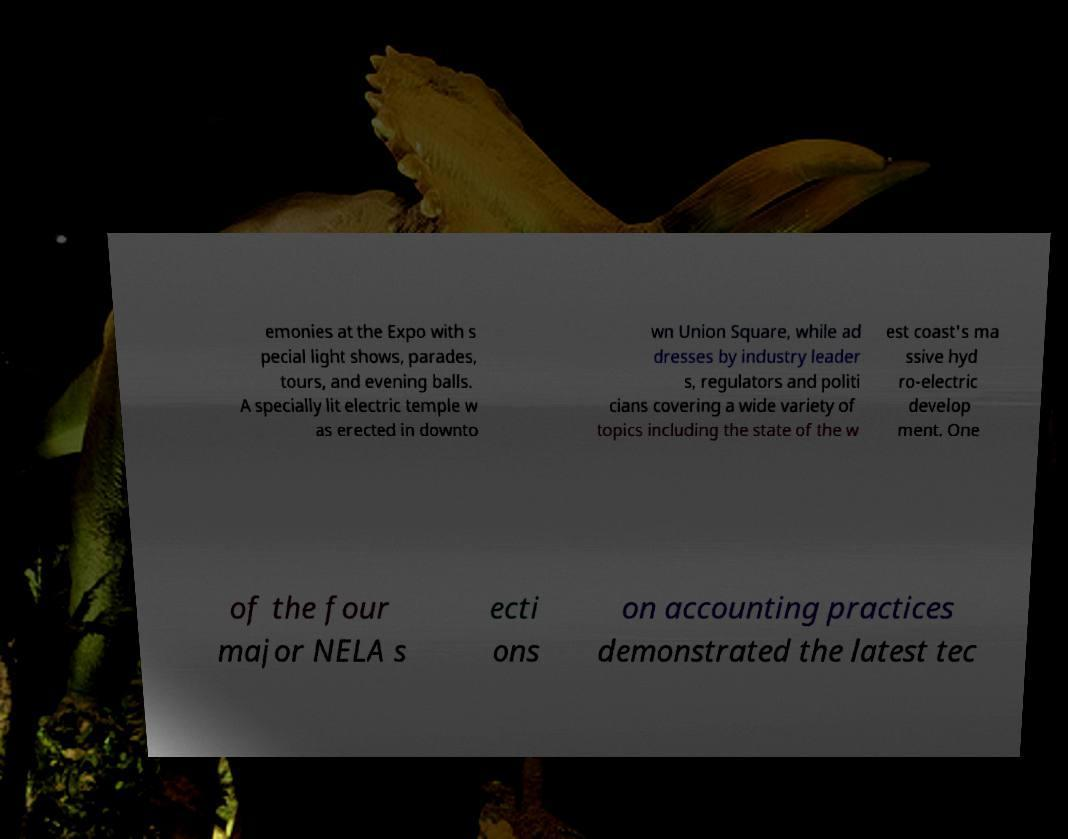Can you read and provide the text displayed in the image?This photo seems to have some interesting text. Can you extract and type it out for me? emonies at the Expo with s pecial light shows, parades, tours, and evening balls. A specially lit electric temple w as erected in downto wn Union Square, while ad dresses by industry leader s, regulators and politi cians covering a wide variety of topics including the state of the w est coast's ma ssive hyd ro-electric develop ment. One of the four major NELA s ecti ons on accounting practices demonstrated the latest tec 